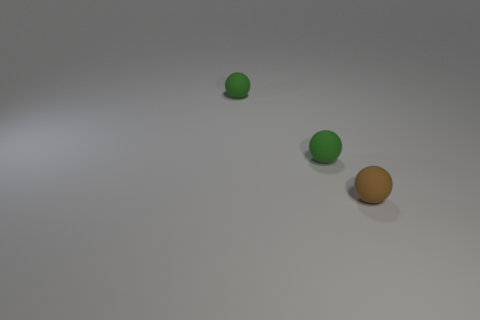Add 3 small green spheres. How many objects exist? 6 Add 1 small green objects. How many small green objects exist? 3 Subtract 1 brown spheres. How many objects are left? 2 Subtract all big gray metal objects. Subtract all green matte objects. How many objects are left? 1 Add 3 small brown objects. How many small brown objects are left? 4 